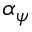Convert formula to latex. <formula><loc_0><loc_0><loc_500><loc_500>\alpha _ { \psi }</formula> 